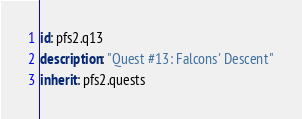<code> <loc_0><loc_0><loc_500><loc_500><_YAML_>id: pfs2.q13
description: "Quest #13: Falcons' Descent"
inherit: pfs2.quests
</code> 